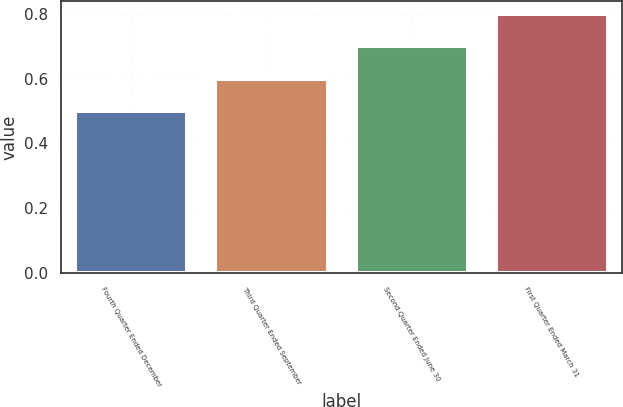Convert chart. <chart><loc_0><loc_0><loc_500><loc_500><bar_chart><fcel>Fourth Quarter Ended December<fcel>Third Quarter Ended September<fcel>Second Quarter Ended June 30<fcel>First Quarter Ended March 31<nl><fcel>0.5<fcel>0.6<fcel>0.7<fcel>0.8<nl></chart> 